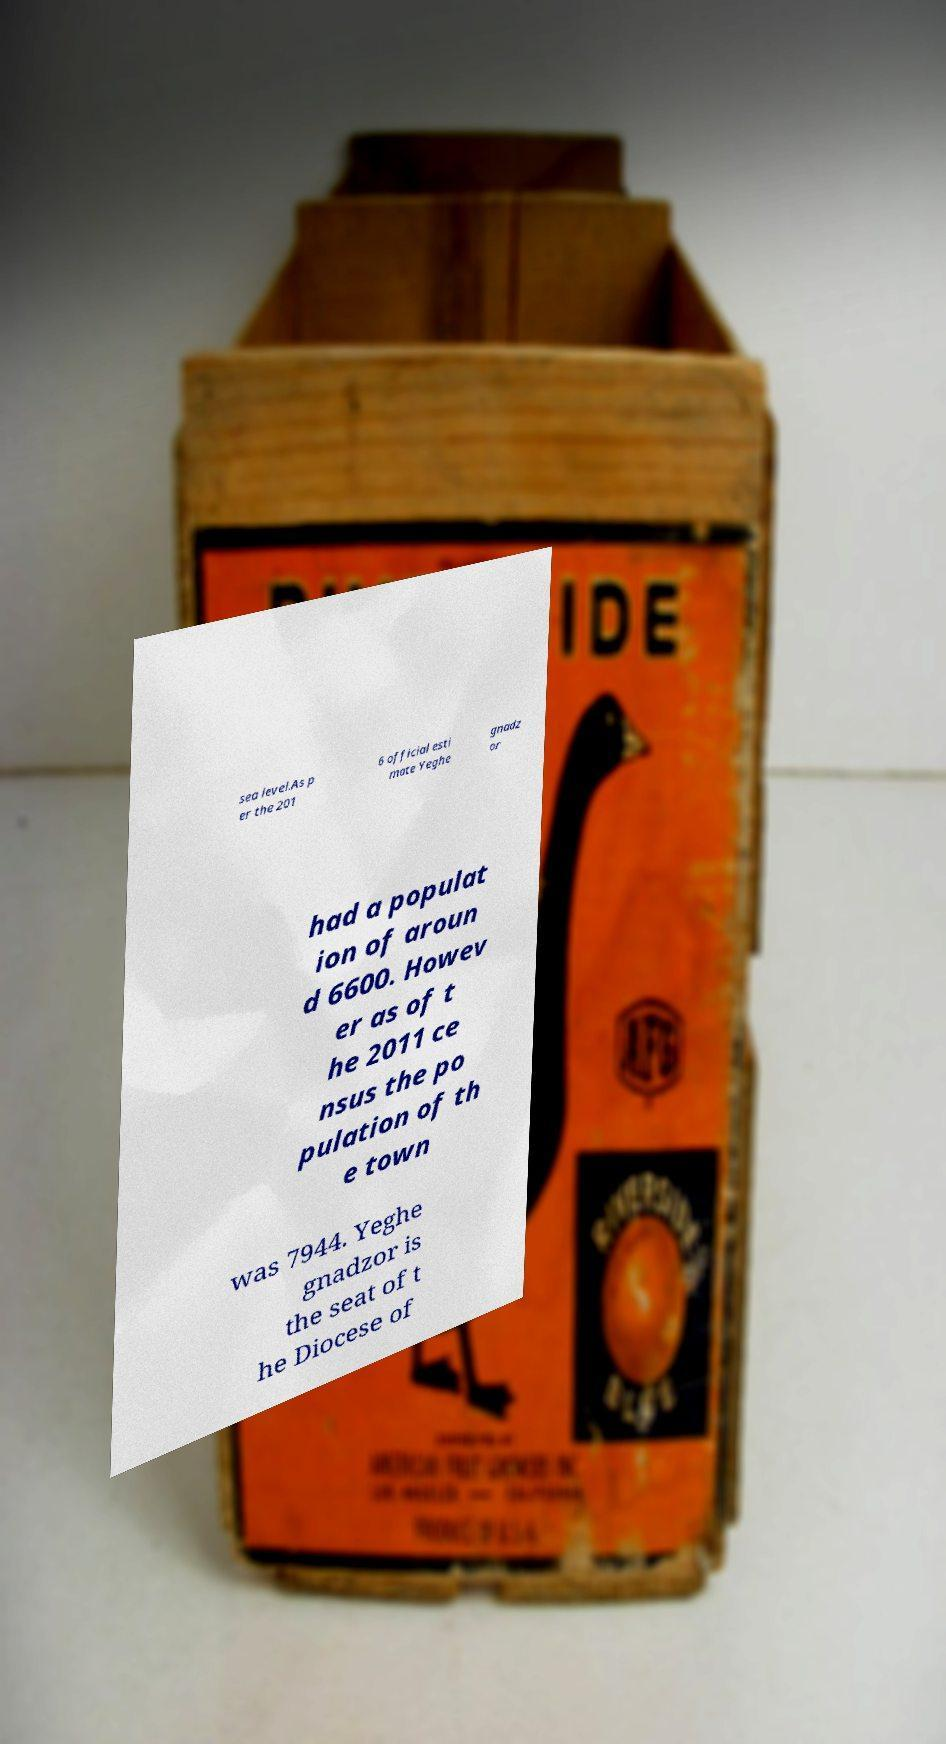Could you extract and type out the text from this image? sea level.As p er the 201 6 official esti mate Yeghe gnadz or had a populat ion of aroun d 6600. Howev er as of t he 2011 ce nsus the po pulation of th e town was 7944. Yeghe gnadzor is the seat of t he Diocese of 